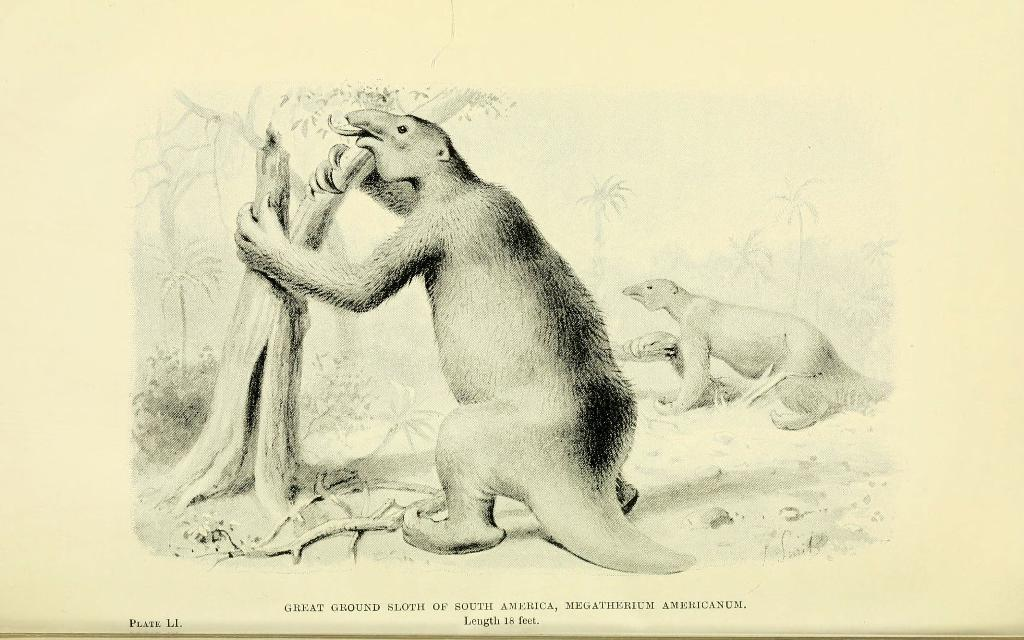What is depicted on the paper in the image? There are pictures of two animals on a paper. Can you describe the position of the first animal? The first animal is holding the branch of a tree. Where can the animals be seen playing in the image? There is no indication in the image that the animals are playing, and no location for play is mentioned. 